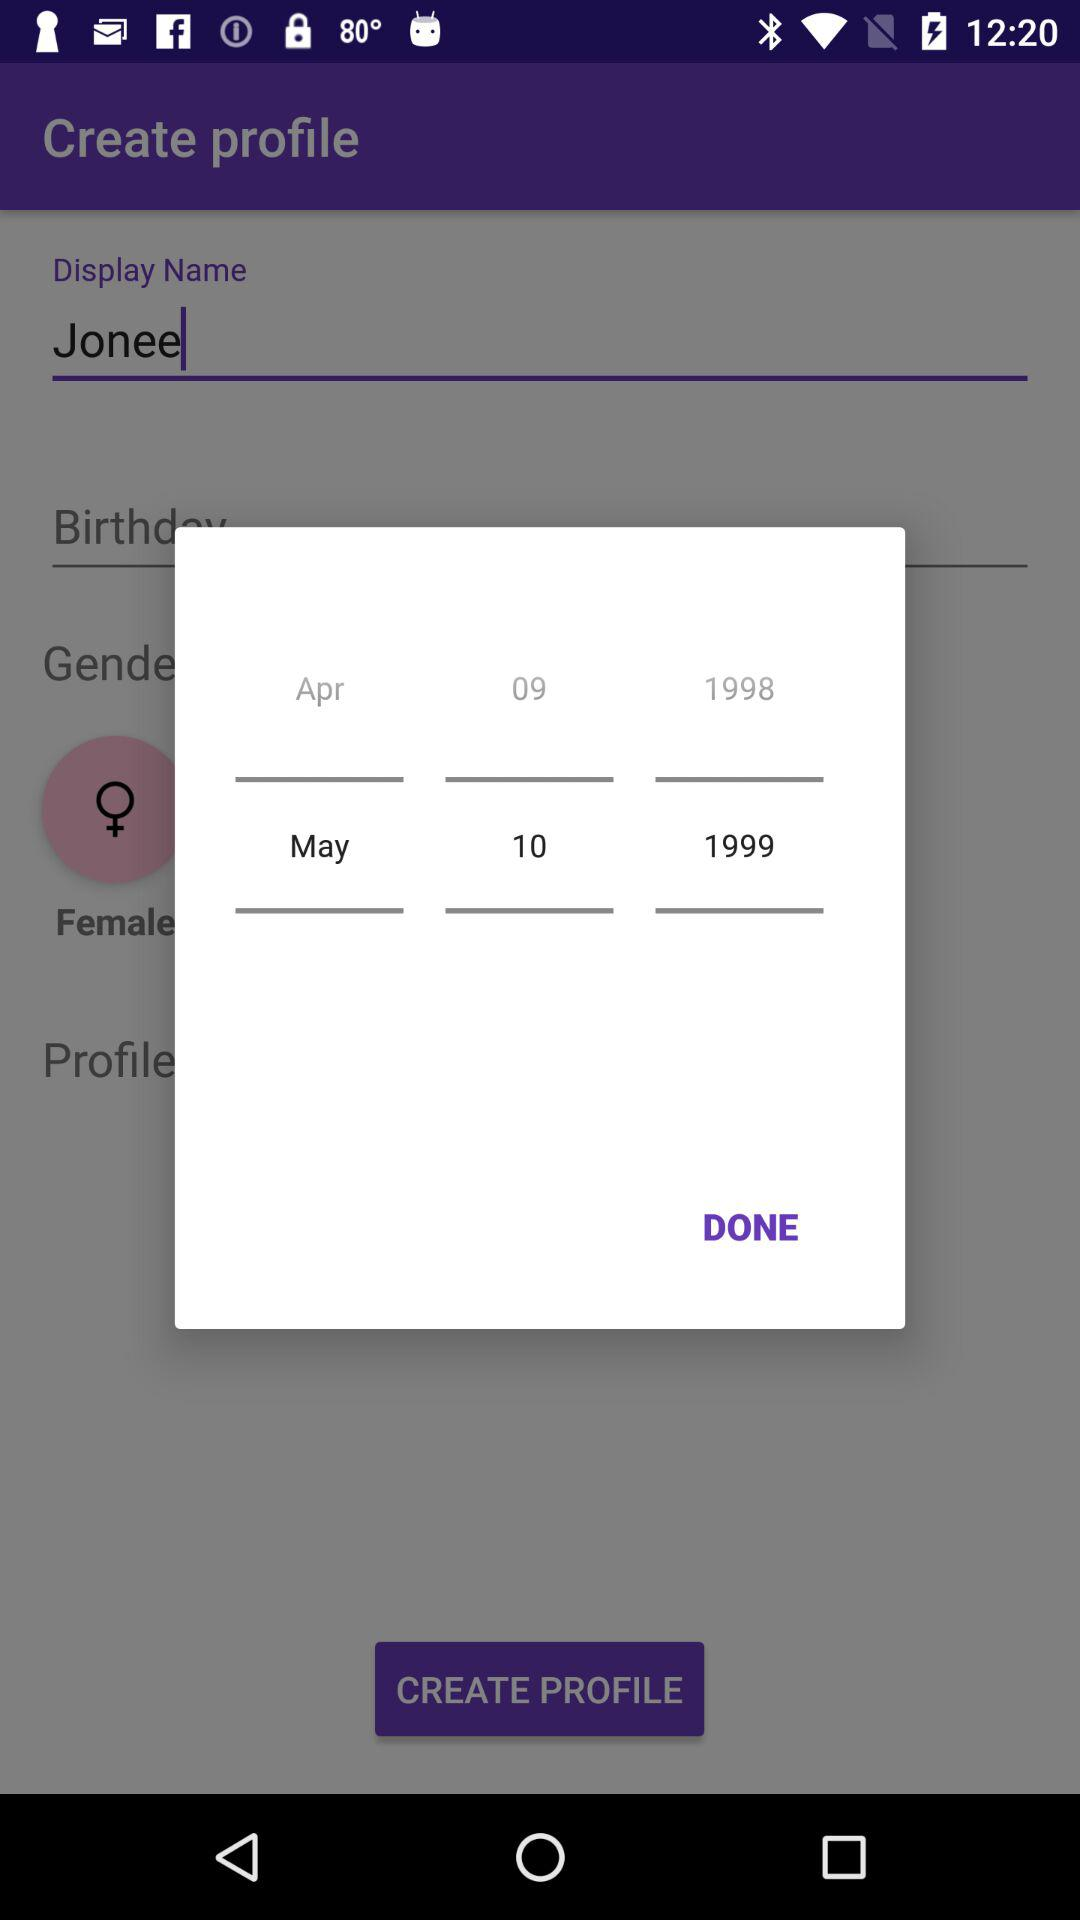What name is displayed? The displayed name is Jonee. 